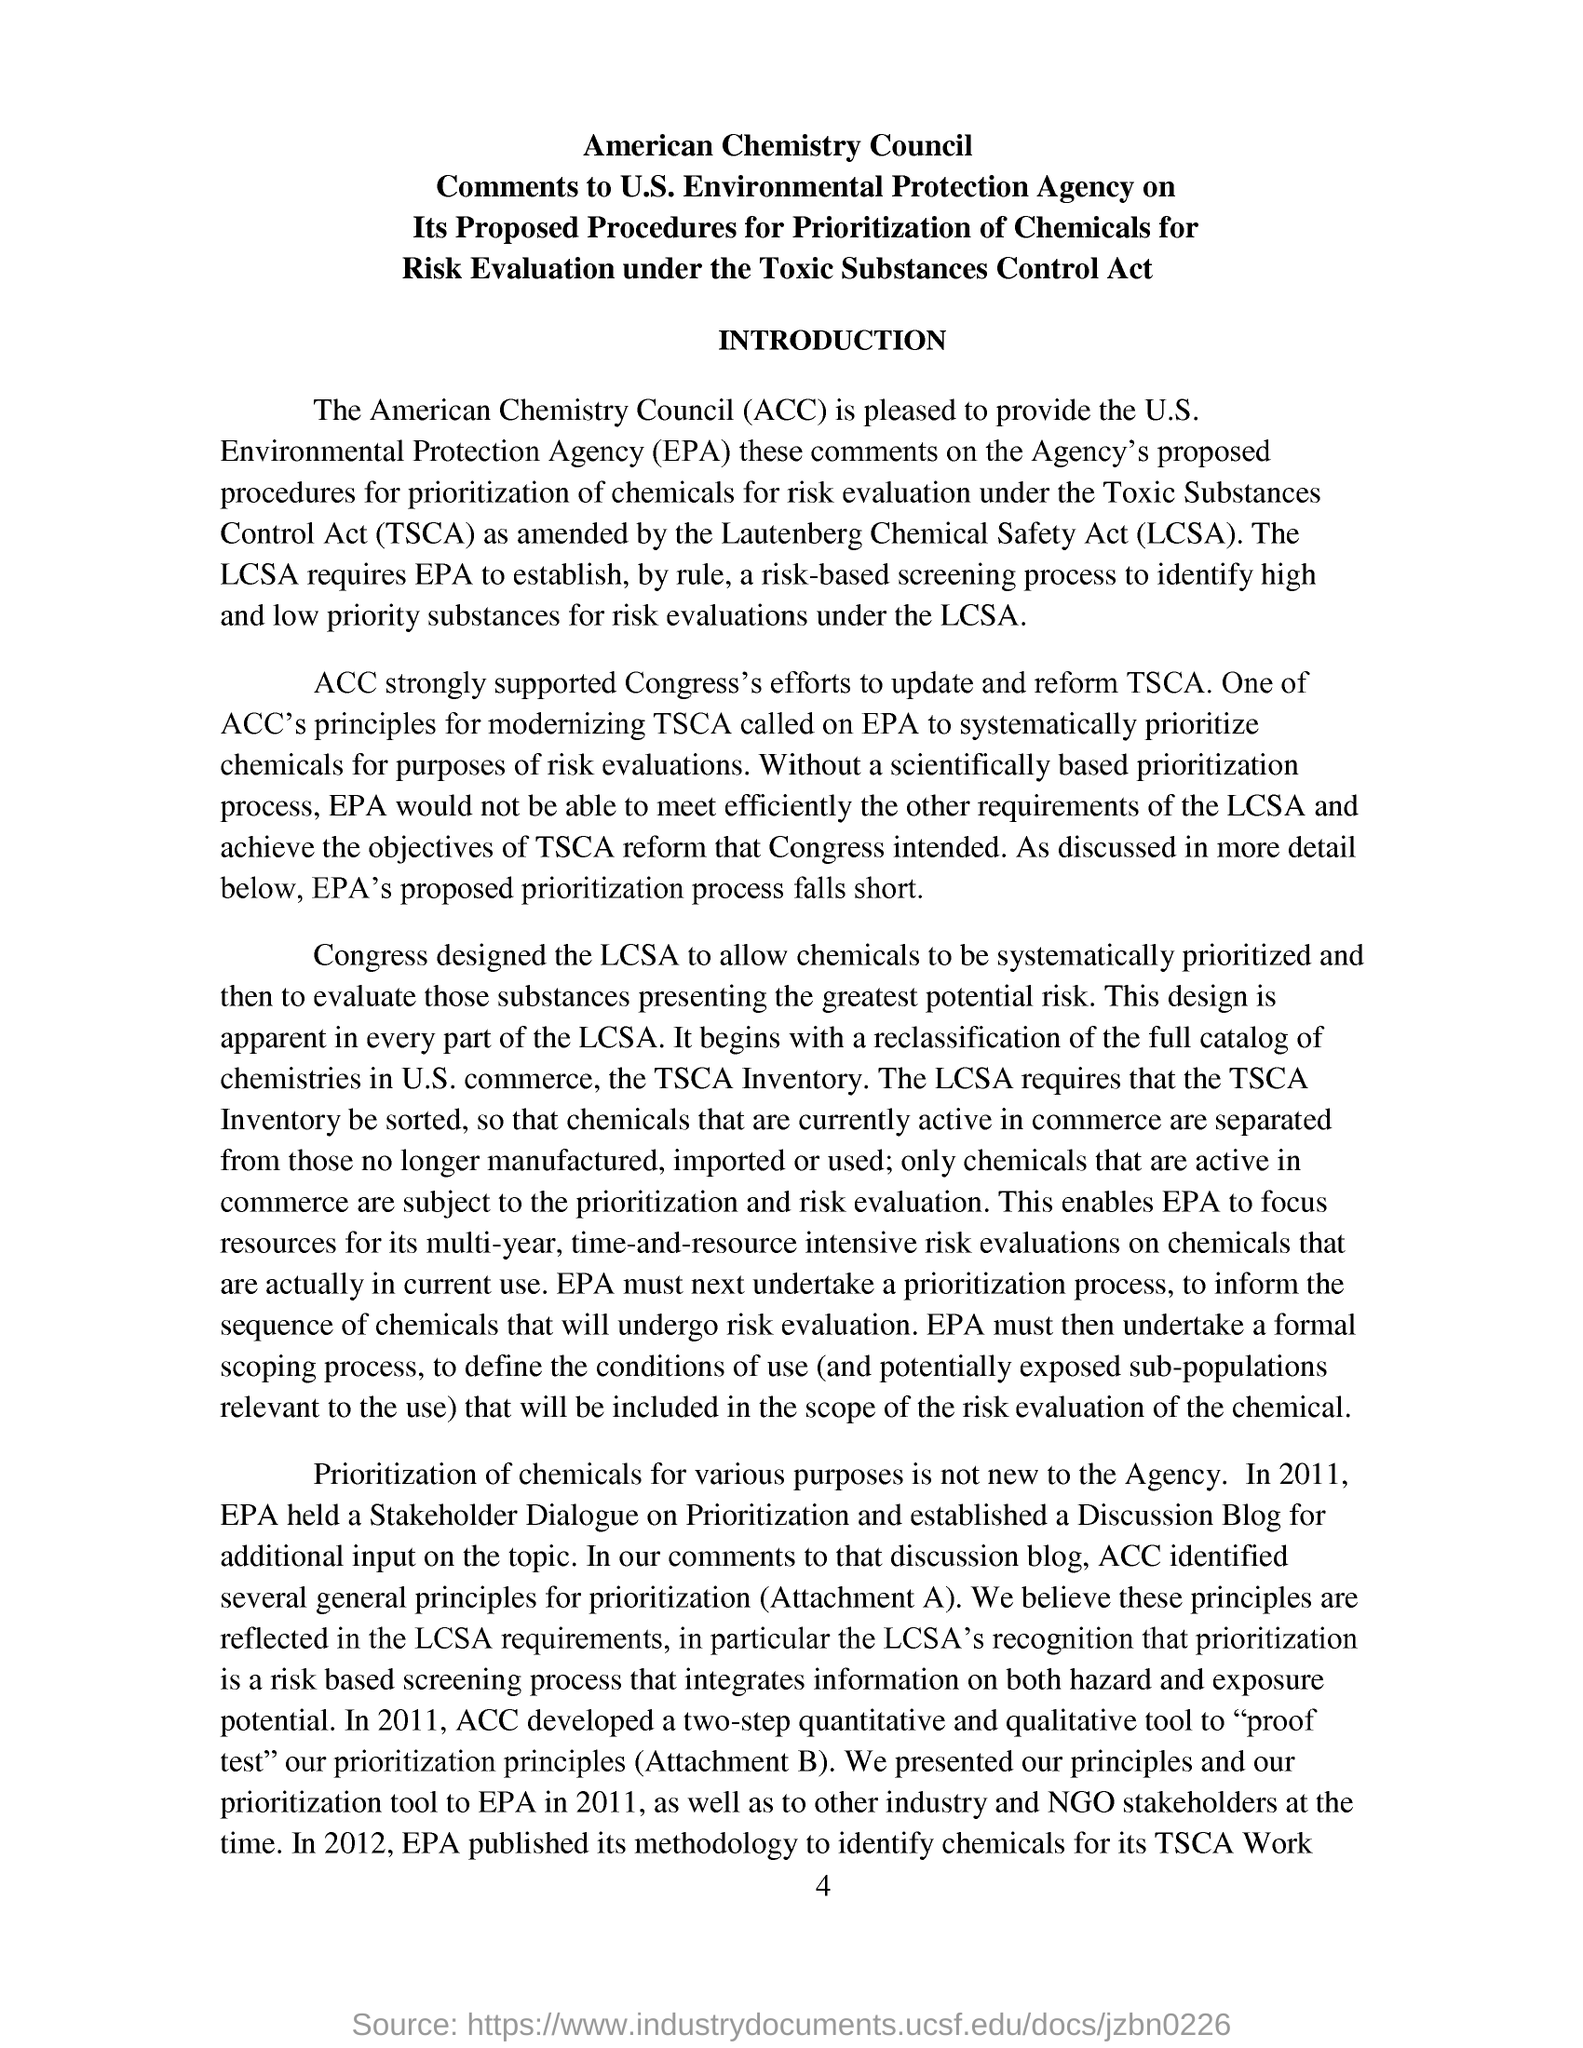What is the fullform of ACC?
Provide a succinct answer. American Chemistry Council. In which year, EPA held a Stakeholder Dialogue on prioritization?
Provide a short and direct response. 2011. Why ACC developed a two-step quantitative and qualitative tool?
Ensure brevity in your answer.  To "proof test" our prioritization principles (attachement b). What is the abbreviation of Toxic Substances Control Act?
Ensure brevity in your answer.  TSCA. What did ACC strongly supported?
Your response must be concise. Supported congress's efforts to update & reform tsca. 